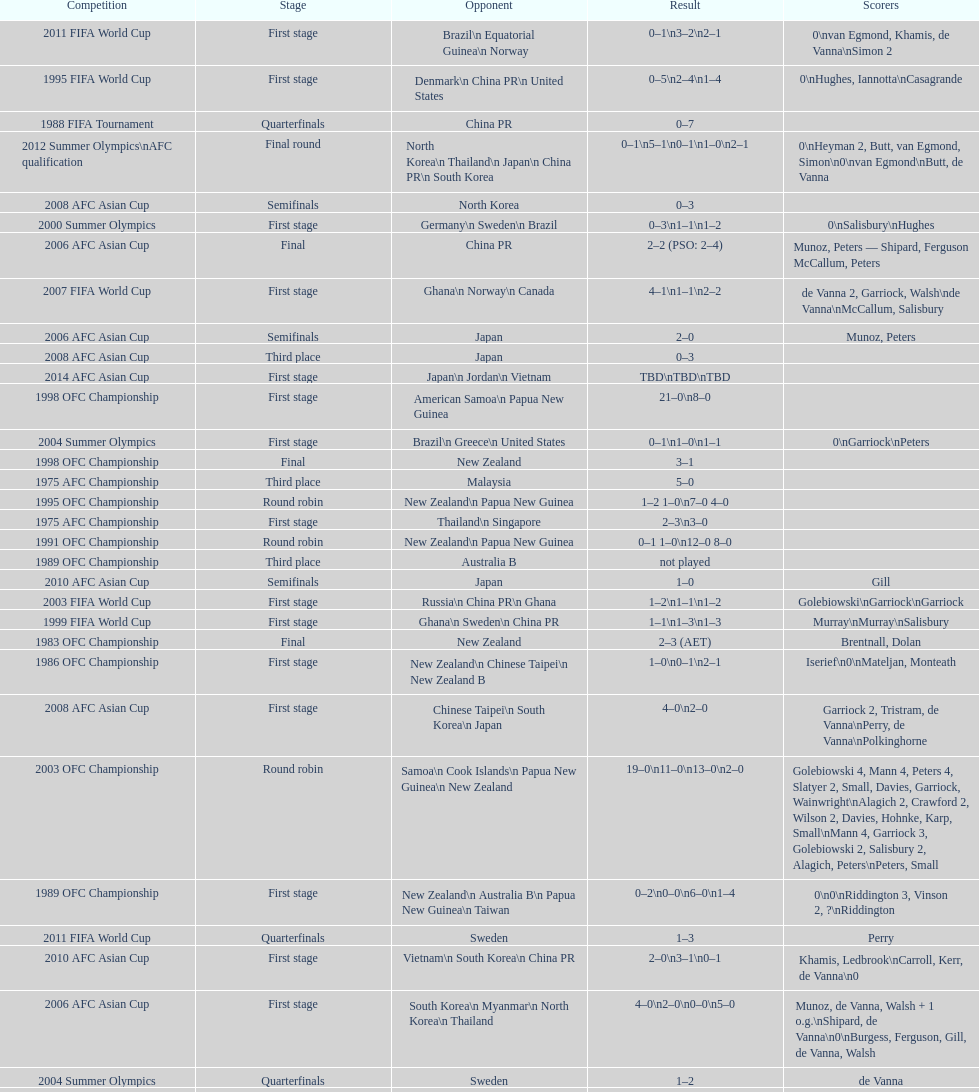How many players scored during the 1983 ofc championship competition? 9. 